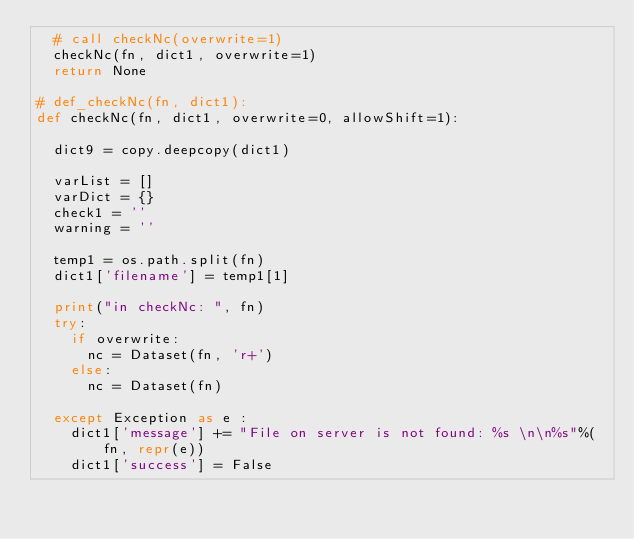<code> <loc_0><loc_0><loc_500><loc_500><_Python_>  # call checkNc(overwrite=1)
  checkNc(fn, dict1, overwrite=1)
  return None

# def_checkNc(fn, dict1):
def checkNc(fn, dict1, overwrite=0, allowShift=1):

  dict9 = copy.deepcopy(dict1)

  varList = []
  varDict = {}
  check1 = ''
  warning = ''

  temp1 = os.path.split(fn)
  dict1['filename'] = temp1[1]

  print("in checkNc: ", fn)
  try:
    if overwrite:
      nc = Dataset(fn, 'r+')
    else:
      nc = Dataset(fn)

  except Exception as e :
    dict1['message'] += "File on server is not found: %s \n\n%s"%(fn, repr(e))
    dict1['success'] = False</code> 